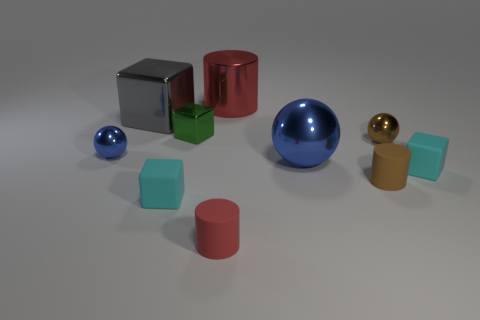Are there more small rubber cylinders left of the big red cylinder than tiny cyan matte things that are behind the green metallic object?
Your answer should be compact. Yes. What number of cubes are brown things or small red objects?
Give a very brief answer. 0. How many things are either red objects behind the large gray metal cube or small red rubber cylinders?
Your answer should be compact. 2. What shape is the cyan rubber object in front of the cyan block to the right of the small block on the left side of the tiny metallic block?
Provide a short and direct response. Cube. How many other small things have the same shape as the red metal thing?
Keep it short and to the point. 2. There is a thing that is the same color as the big metal cylinder; what is it made of?
Your response must be concise. Rubber. Is the big red cylinder made of the same material as the tiny blue ball?
Give a very brief answer. Yes. What number of red objects are in front of the matte block behind the small cyan matte block on the left side of the big sphere?
Your answer should be compact. 1. Is there a big object that has the same material as the large cylinder?
Ensure brevity in your answer.  Yes. There is a rubber thing that is the same color as the large cylinder; what is its size?
Your answer should be very brief. Small. 